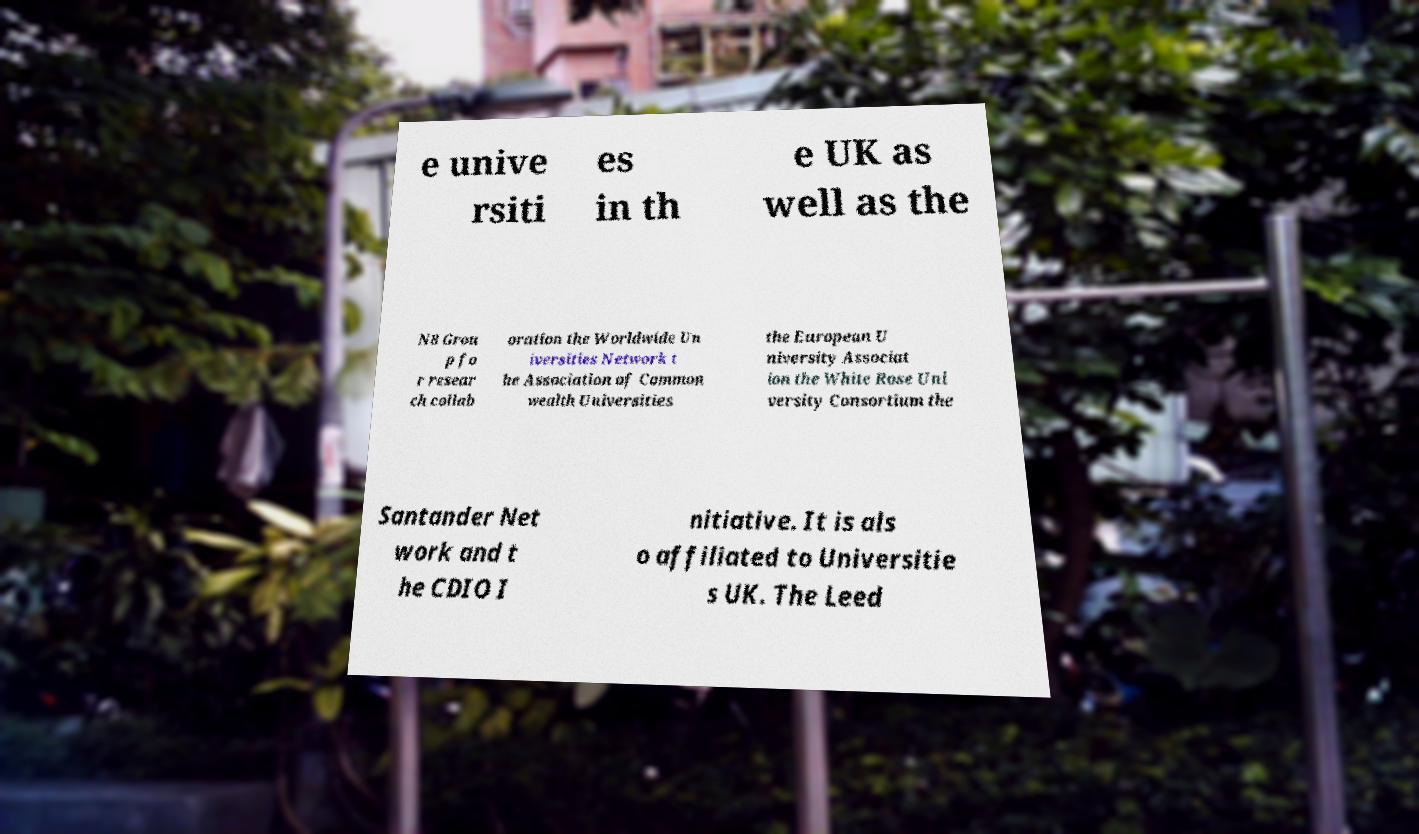For documentation purposes, I need the text within this image transcribed. Could you provide that? e unive rsiti es in th e UK as well as the N8 Grou p fo r resear ch collab oration the Worldwide Un iversities Network t he Association of Common wealth Universities the European U niversity Associat ion the White Rose Uni versity Consortium the Santander Net work and t he CDIO I nitiative. It is als o affiliated to Universitie s UK. The Leed 